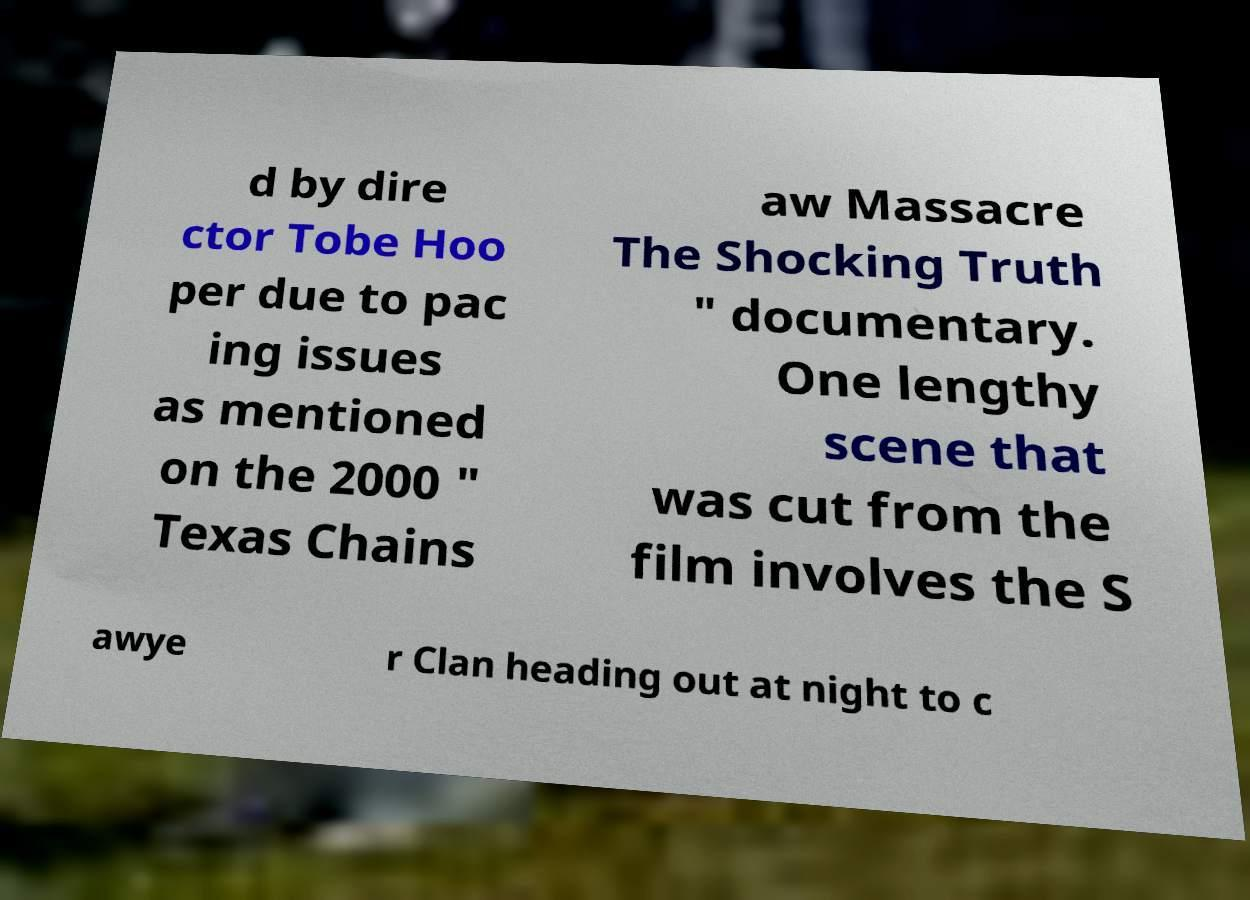I need the written content from this picture converted into text. Can you do that? d by dire ctor Tobe Hoo per due to pac ing issues as mentioned on the 2000 " Texas Chains aw Massacre The Shocking Truth " documentary. One lengthy scene that was cut from the film involves the S awye r Clan heading out at night to c 